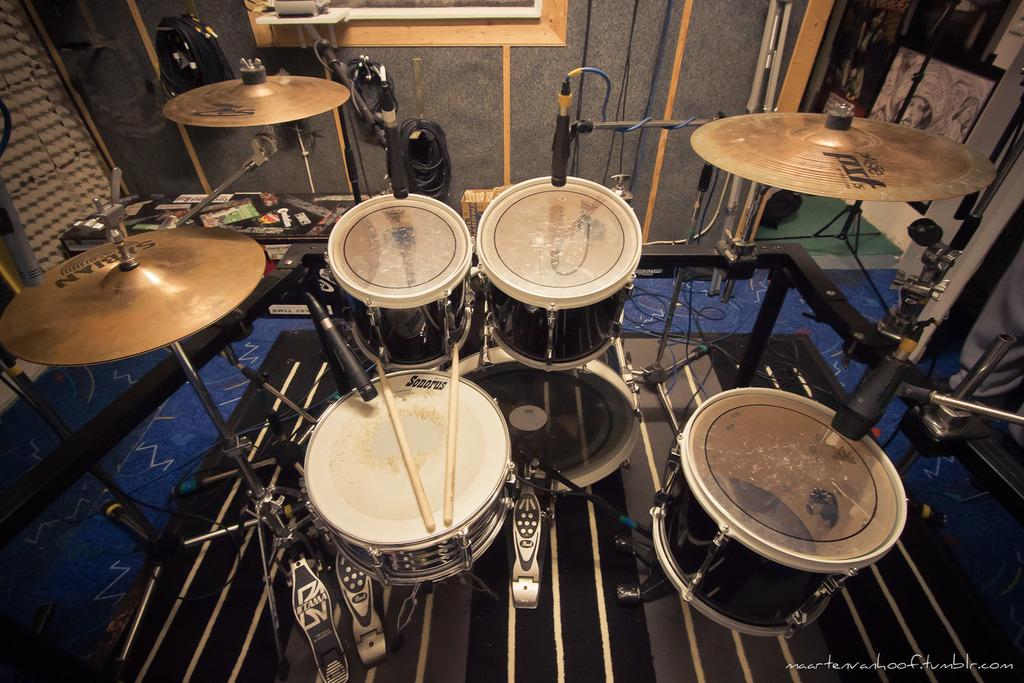What type of musical instruments can be seen in the image? There are drums in the image, along with other musical instruments. Can you describe the other musical instruments in the image? Unfortunately, the provided facts do not specify the other musical instruments in the image. However, we can confirm that there are drums and at least one other musical instrument present. How many robins can be seen sitting on the drums in the image? There are no robins present in the image; it features musical instruments, including drums. 